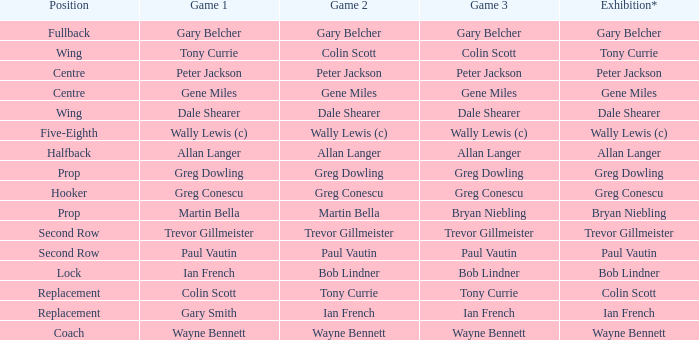In game 1, what is the place occupied by colin scott? Replacement. Would you mind parsing the complete table? {'header': ['Position', 'Game 1', 'Game 2', 'Game 3', 'Exhibition*'], 'rows': [['Fullback', 'Gary Belcher', 'Gary Belcher', 'Gary Belcher', 'Gary Belcher'], ['Wing', 'Tony Currie', 'Colin Scott', 'Colin Scott', 'Tony Currie'], ['Centre', 'Peter Jackson', 'Peter Jackson', 'Peter Jackson', 'Peter Jackson'], ['Centre', 'Gene Miles', 'Gene Miles', 'Gene Miles', 'Gene Miles'], ['Wing', 'Dale Shearer', 'Dale Shearer', 'Dale Shearer', 'Dale Shearer'], ['Five-Eighth', 'Wally Lewis (c)', 'Wally Lewis (c)', 'Wally Lewis (c)', 'Wally Lewis (c)'], ['Halfback', 'Allan Langer', 'Allan Langer', 'Allan Langer', 'Allan Langer'], ['Prop', 'Greg Dowling', 'Greg Dowling', 'Greg Dowling', 'Greg Dowling'], ['Hooker', 'Greg Conescu', 'Greg Conescu', 'Greg Conescu', 'Greg Conescu'], ['Prop', 'Martin Bella', 'Martin Bella', 'Bryan Niebling', 'Bryan Niebling'], ['Second Row', 'Trevor Gillmeister', 'Trevor Gillmeister', 'Trevor Gillmeister', 'Trevor Gillmeister'], ['Second Row', 'Paul Vautin', 'Paul Vautin', 'Paul Vautin', 'Paul Vautin'], ['Lock', 'Ian French', 'Bob Lindner', 'Bob Lindner', 'Bob Lindner'], ['Replacement', 'Colin Scott', 'Tony Currie', 'Tony Currie', 'Colin Scott'], ['Replacement', 'Gary Smith', 'Ian French', 'Ian French', 'Ian French'], ['Coach', 'Wayne Bennett', 'Wayne Bennett', 'Wayne Bennett', 'Wayne Bennett']]} 